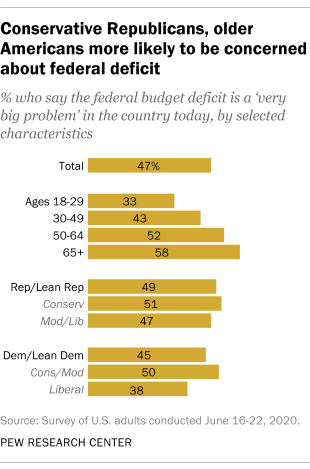Point out several critical features in this image. According to the data, approximately 58% of the population is 65 years old or older. There are two age groups that are above the total average of 47%. 